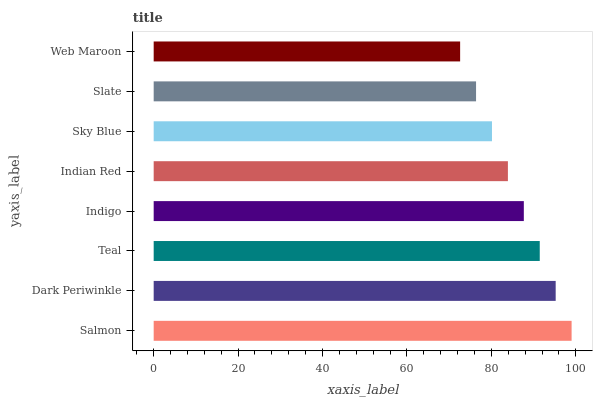Is Web Maroon the minimum?
Answer yes or no. Yes. Is Salmon the maximum?
Answer yes or no. Yes. Is Dark Periwinkle the minimum?
Answer yes or no. No. Is Dark Periwinkle the maximum?
Answer yes or no. No. Is Salmon greater than Dark Periwinkle?
Answer yes or no. Yes. Is Dark Periwinkle less than Salmon?
Answer yes or no. Yes. Is Dark Periwinkle greater than Salmon?
Answer yes or no. No. Is Salmon less than Dark Periwinkle?
Answer yes or no. No. Is Indigo the high median?
Answer yes or no. Yes. Is Indian Red the low median?
Answer yes or no. Yes. Is Sky Blue the high median?
Answer yes or no. No. Is Dark Periwinkle the low median?
Answer yes or no. No. 